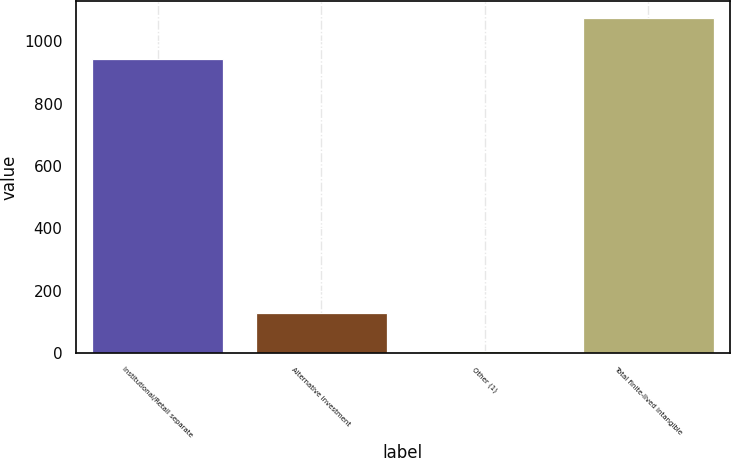Convert chart to OTSL. <chart><loc_0><loc_0><loc_500><loc_500><bar_chart><fcel>Institutional/Retail separate<fcel>Alternative investment<fcel>Other (1)<fcel>Total finite-lived intangible<nl><fcel>942<fcel>128<fcel>5<fcel>1075<nl></chart> 